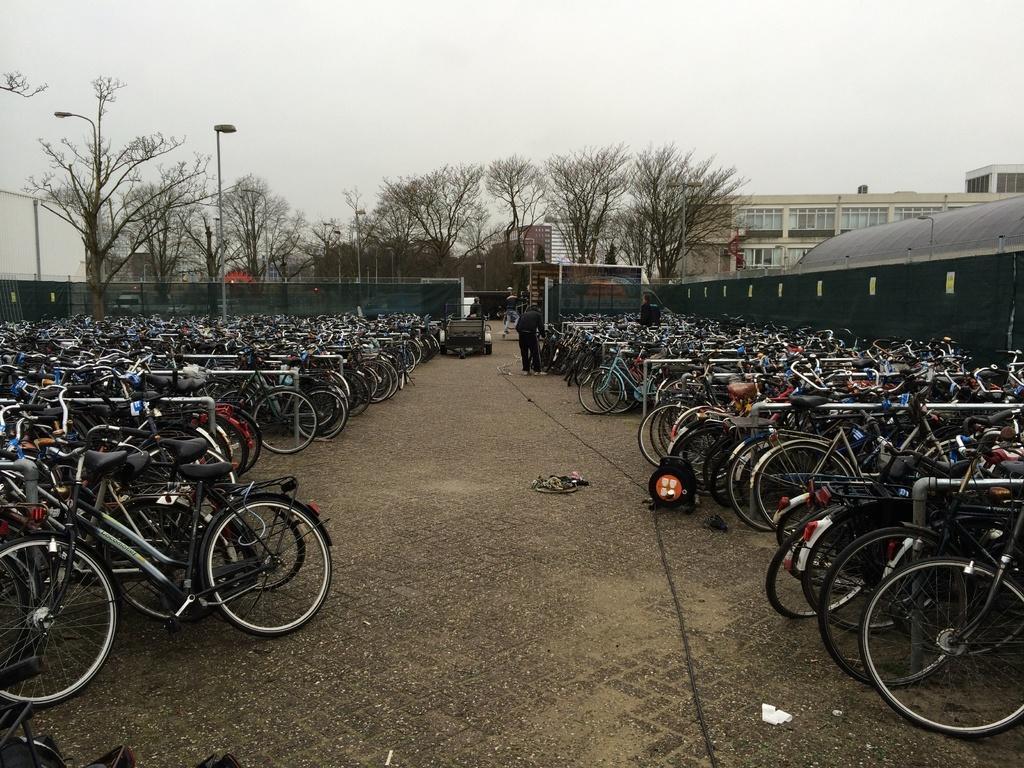Could you give a brief overview of what you see in this image? In this image we can see cycle parking lot. Background of the image buildings, trees and poles are available. The sky is in white color. 